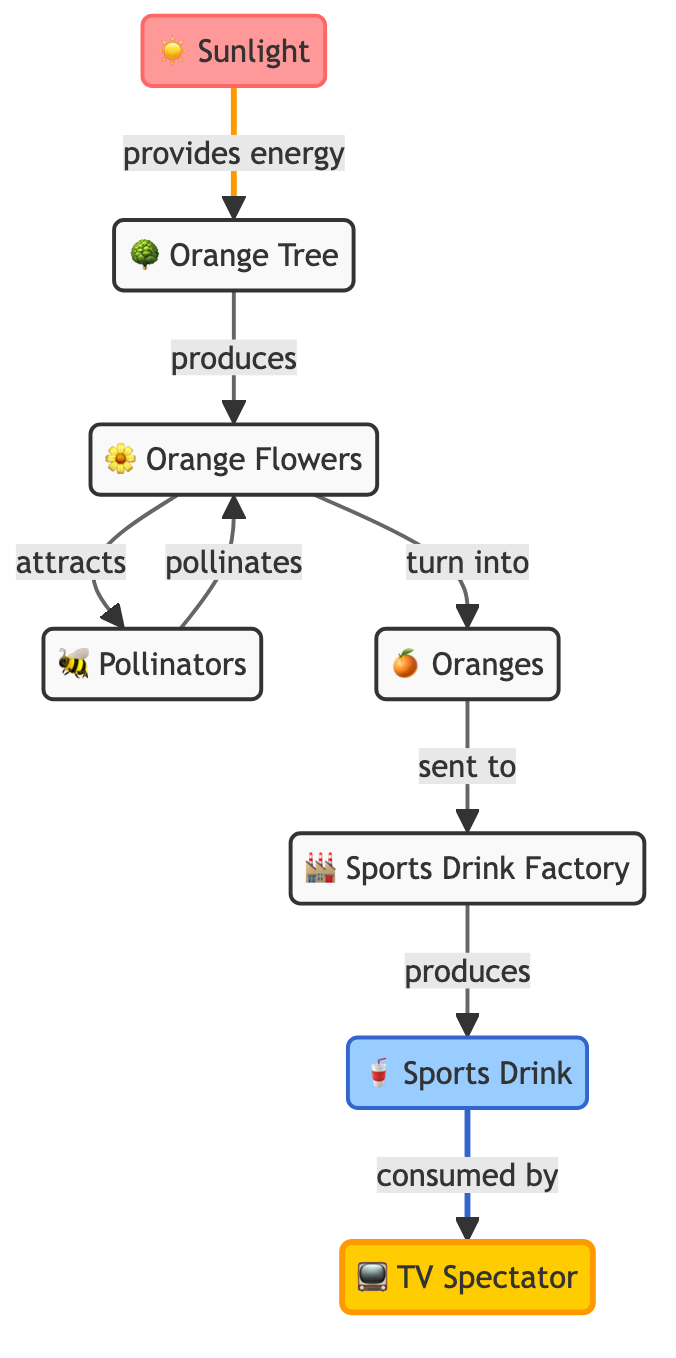What provides energy to the orange tree? The diagram shows that sunlight is the source providing energy to the orange tree. This is indicated by the direct connection from the sunlight node to the orange tree node.
Answer: Sunlight How many products are indicated in the diagram? The diagram shows two products: oranges and the sports drink. By counting the nodes labeled with products, we find the total is two.
Answer: Two What attracts pollinators? The diagram shows that flowers attract pollinators, which is indicated by the arrow connecting the flowers node to the pollinators node.
Answer: Flowers What role does the factory play in the food chain? The factory takes in oranges and produces the sports drink, as shown by the directed flow from the oranges node to the factory node and then to the sports drink node.
Answer: Produces Which node comes after the pollinators in the flow? Following the pollinators in the diagram, the next node is flowers, as indicated by the arrow from the pollinators node pointing back to the flowers node.
Answer: Flowers What is the final consumer in this food chain? The final consumer in the diagram is the TV spectator, as indicated by the arrow pointing from the sports drink node to the TV spectator node.
Answer: TV Spectator How does pollination of flowers affect the production of oranges? Pollinators directly impact the production of oranges by pollinating the flowers; without this process, the flowers would not turn into oranges as indicated by the flow to the oranges node.
Answer: Pollinates What is the relationship between oranges and the sports drink? The relationship is that oranges are sent to the factory which produces the sports drink, as indicated by the flow from the oranges node to the factory node and then to the sports drink node.
Answer: Oranges to Factory How many steps are involved from sunlight to sports drink? The steps can be counted by tracing the flow from sunlight → orange tree → flowers → pollinators → flowers → oranges → factory → sports drink, which totals seven steps.
Answer: Seven 